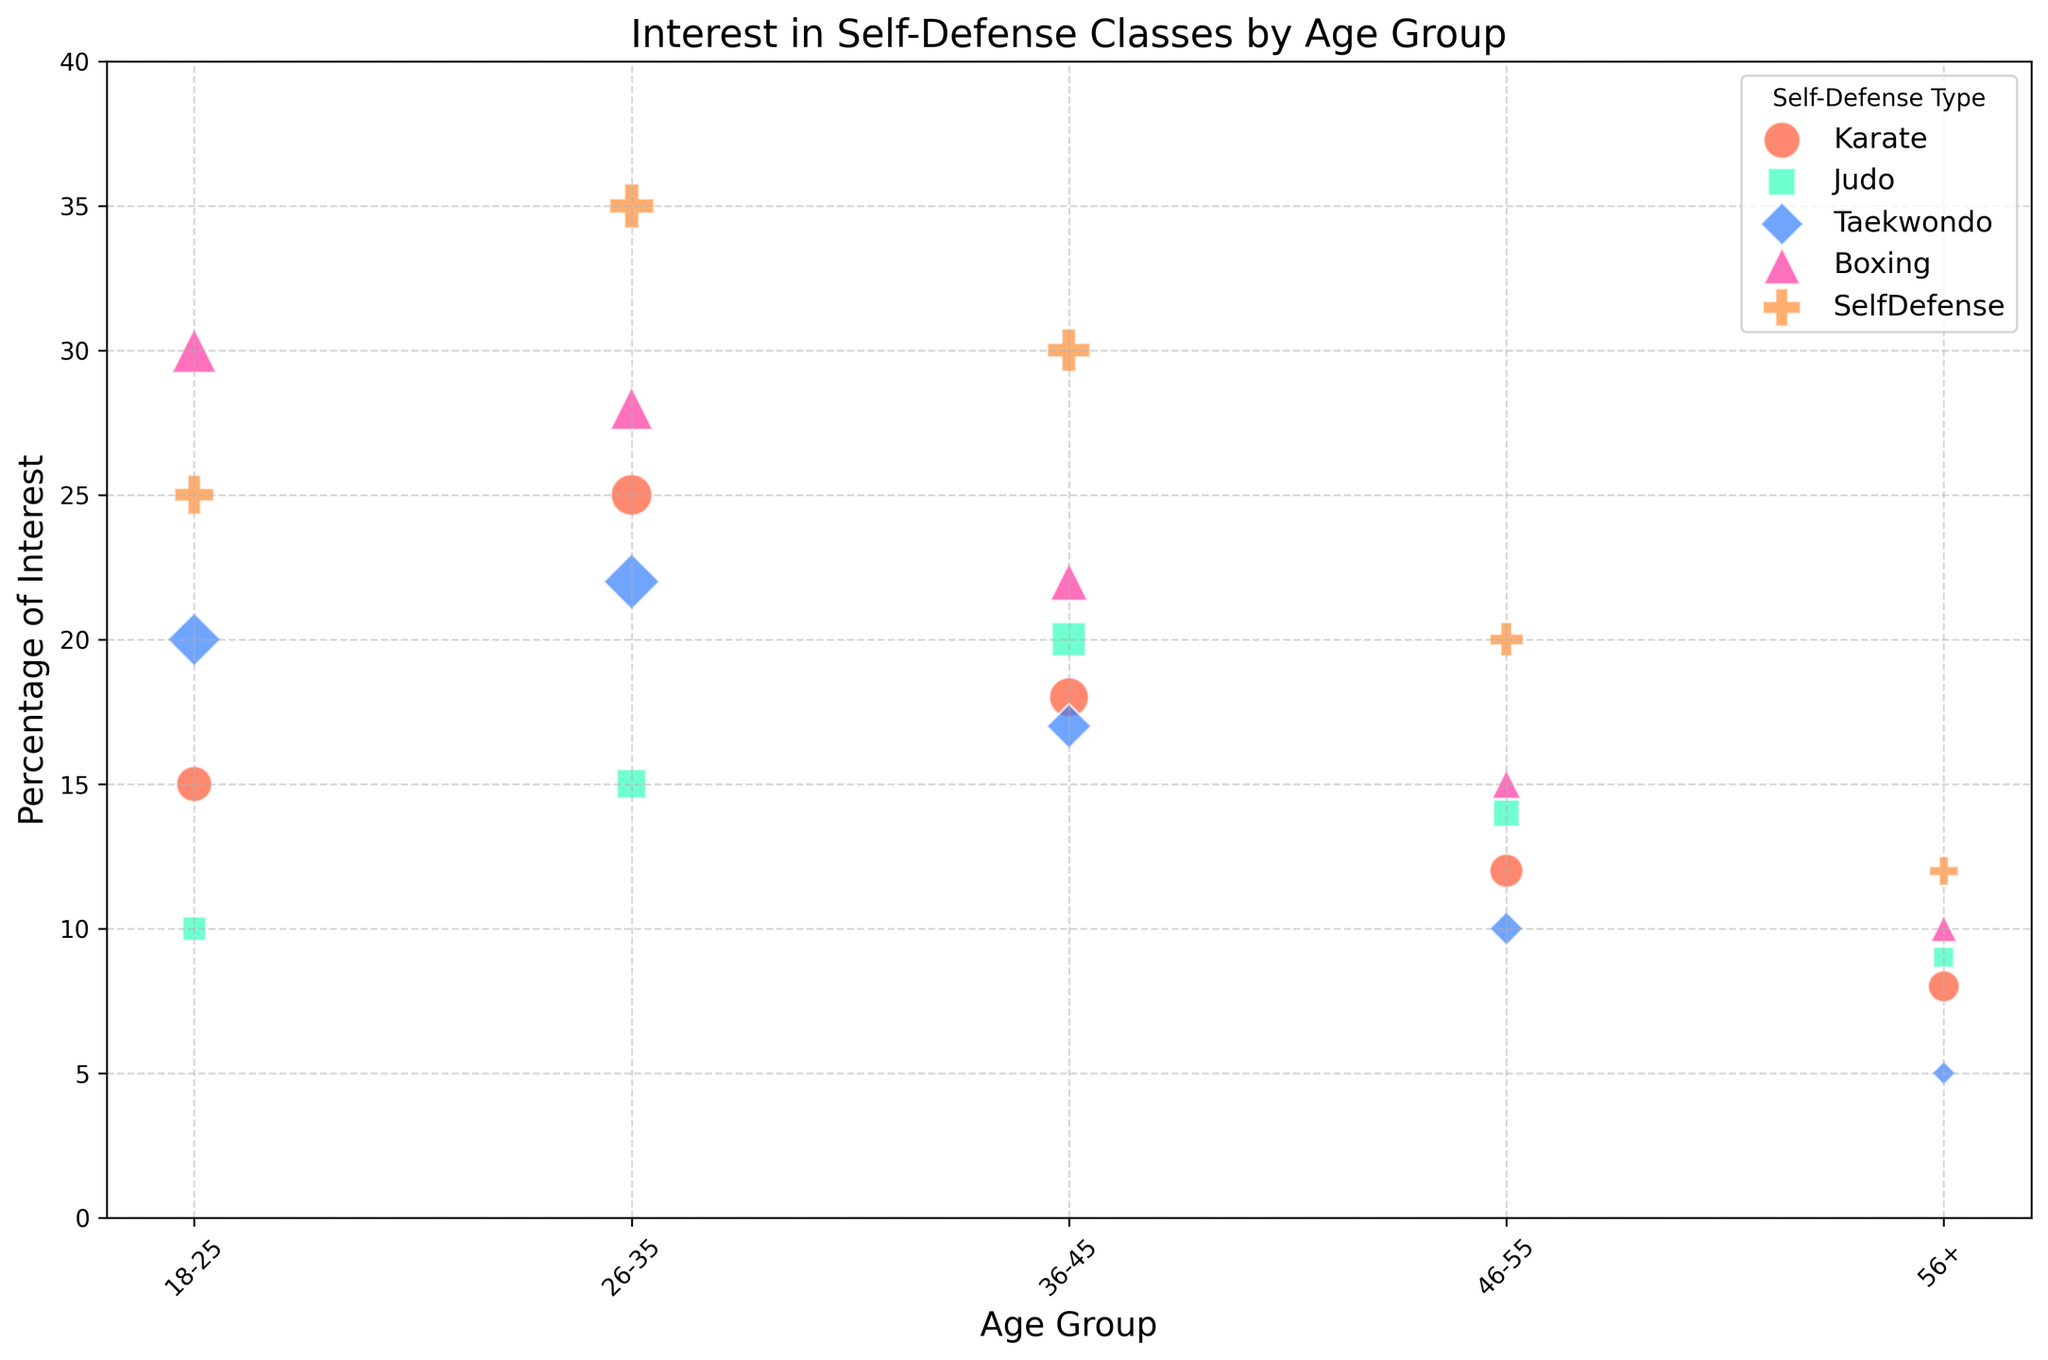Which age group has the highest interest in Boxing? By observing the height of the bubbles for Boxing, the 18-25 age group reaches the highest point on the y-axis, indicating the highest interest percentage.
Answer: 18-25 Which type of self-defense training has the highest interest across all age groups? The self-defense type with the largest bubble for the highest point on the y-axis is Boxing in the 18-25 age group at 30%.
Answer: Boxing How does interest in Karate change from the 26-35 age group to the 56+ age group? The interest in Karate decreases from 25% in the 26-35 age group to 8% in the 56+ group, as seen by the descending height of the bubbles.
Answer: Decreases Which age group shows the least interest in Taekwondo and what percentage is it? The smallest Taekwondo bubble on the y-axis is for the 56+ group at 5%.
Answer: 56+, 5% Calculate the average percentage of interest in Judo for all age groups. Add the percentages (10 + 15 + 20 + 14 + 9) and divide by the number of age groups (5). (10 + 15 + 20 + 14 + 9) / 5 = 13.6%
Answer: 13.6% Compare the size of the interest bubbles for SelfDefense and Boxing for the 36-45 age group. The bubbles' sizes are 65 units for SelfDefense and 50 units for Boxing, reflecting a larger interest in SelfDefense in this group.
Answer: Larger for SelfDefense In the 46-55 age group, which self-defense type has the greatest interest percentage and what is it? Find the highest bubble on the y-axis for the 46-55 age group, which is SelfDefense at 20%.
Answer: SelfDefense, 20% What is the visual color associated with Karate on the bubble chart? The Karate bubbles are colored red-orange, as indicated in the color legend.
Answer: Red-orange Which age group shows the most varied interest in different self-defense types in terms of the bubble sizes? The 26-35 age group has different types with the most significant size variations, indicating varied interest.
Answer: 26-35 What is the percentage difference in interest between Judo and Taekwondo for the 18-25 age group? Subtract the percentage interest for Judo (10%) from that for Taekwondo (20%), resulting in a difference of 10%.
Answer: 10% 